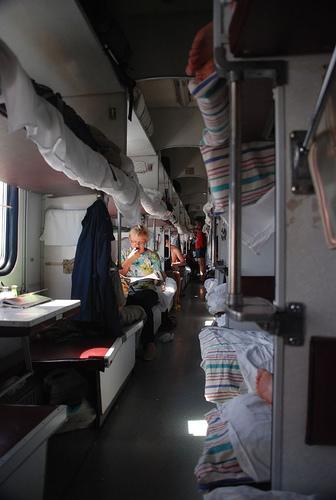How many luggage racks are there?
Quick response, please. 4. Is that folding table made out of wood?
Quick response, please. No. Where are the windows?
Write a very short answer. Left. How many people are in the photo?
Write a very short answer. 3. Is this transportation equipped for people to travel long distances?
Be succinct. Yes. 